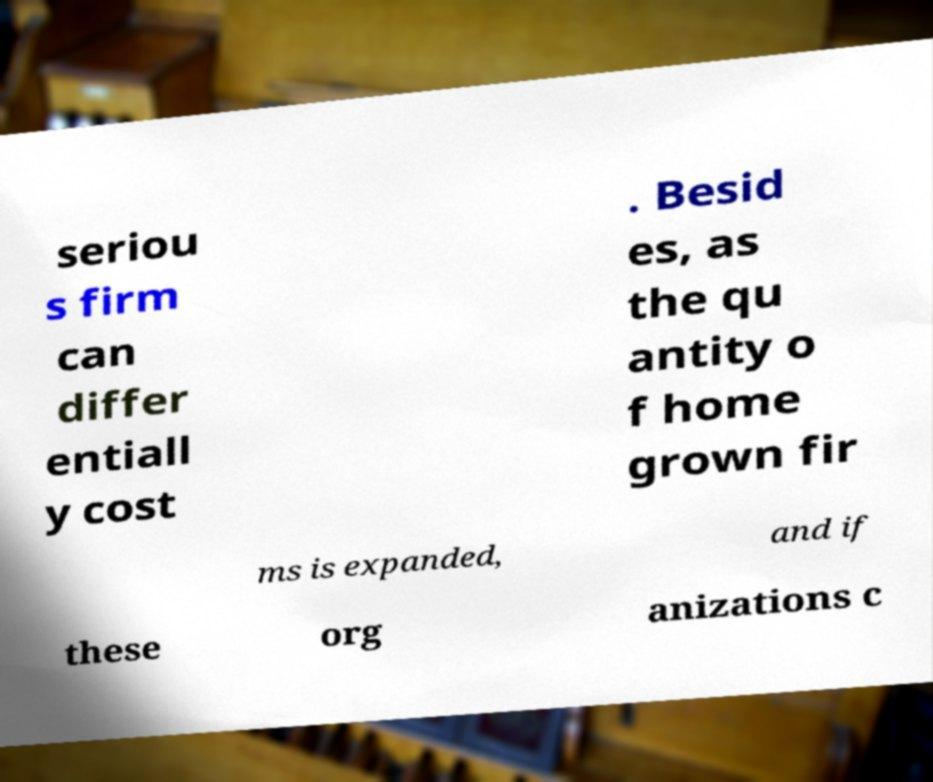Please identify and transcribe the text found in this image. seriou s firm can differ entiall y cost . Besid es, as the qu antity o f home grown fir ms is expanded, and if these org anizations c 